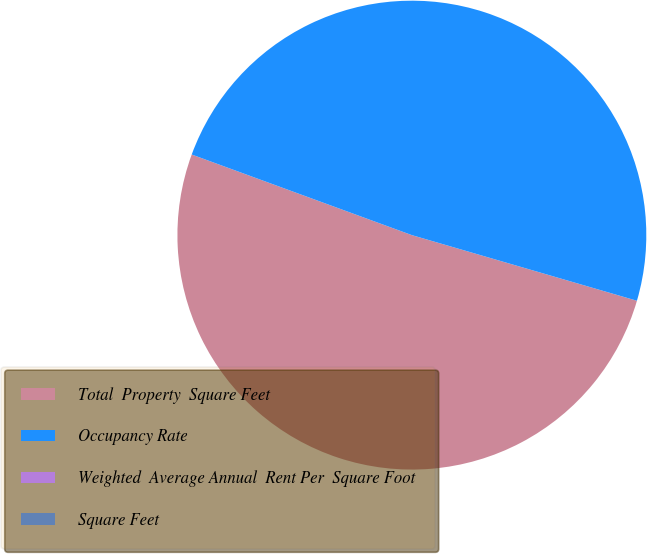Convert chart to OTSL. <chart><loc_0><loc_0><loc_500><loc_500><pie_chart><fcel>Total  Property  Square Feet<fcel>Occupancy Rate<fcel>Weighted  Average Annual  Rent Per  Square Foot<fcel>Square Feet<nl><fcel>51.07%<fcel>48.93%<fcel>0.0%<fcel>0.0%<nl></chart> 